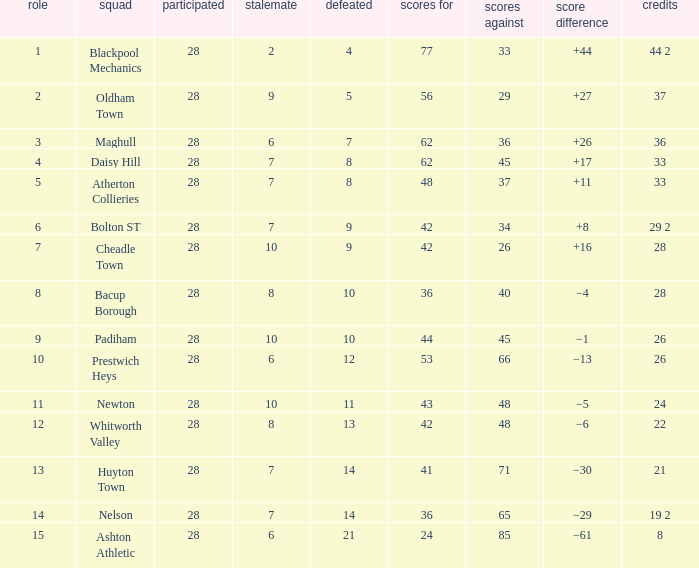For entries with fewer than 28 played, with 45 goals against and points 1 of 33, what is the average drawn? None. 